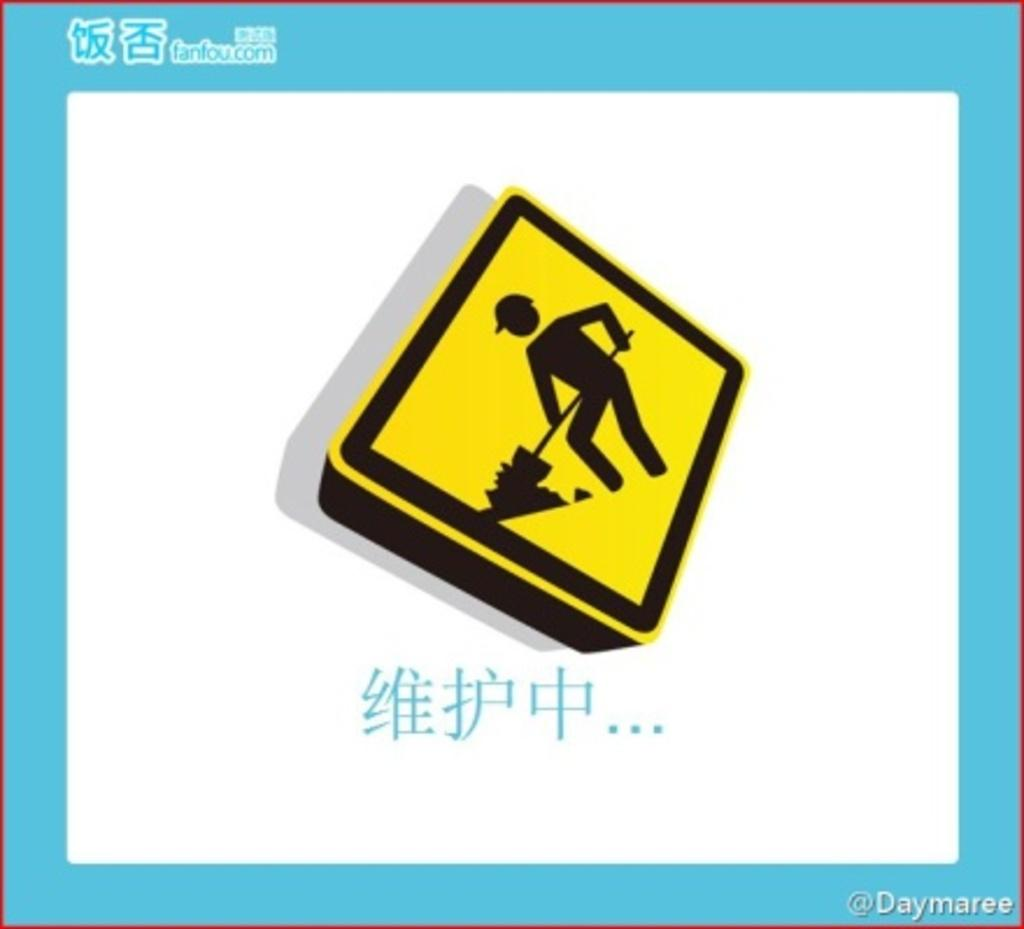<image>
Present a compact description of the photo's key features. A yellow construction caution sign advertising for fanfou.com. 